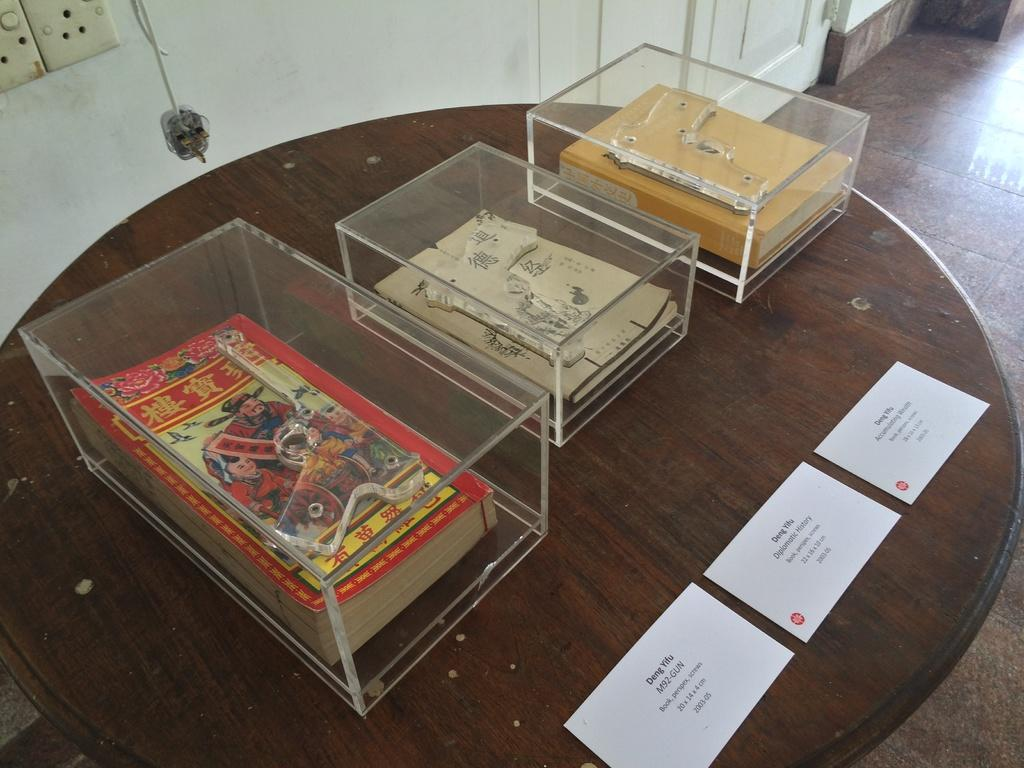What type of table is in the image? There is a wooden table in the image. What is on top of the wooden table? Papers and glass boxes with books are present on the wooden table. What is the floor made of in the image? The floor has tiles. Where can an electrical outlet be found in the image? There is a socket on the wall. How does the quiet atmosphere in the image affect the thunder outside? There is no mention of a quiet atmosphere or thunder in the image, so it's not possible to determine how they might be related. 